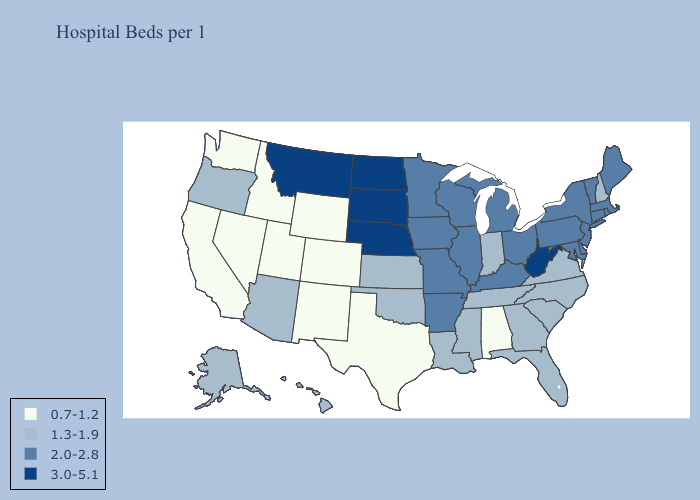Which states hav the highest value in the Northeast?
Quick response, please. Connecticut, Maine, Massachusetts, New Jersey, New York, Pennsylvania, Rhode Island, Vermont. Among the states that border Georgia , which have the lowest value?
Short answer required. Alabama. Does Nebraska have the same value as Kentucky?
Write a very short answer. No. Which states have the highest value in the USA?
Write a very short answer. Montana, Nebraska, North Dakota, South Dakota, West Virginia. What is the highest value in states that border Kansas?
Concise answer only. 3.0-5.1. What is the value of Rhode Island?
Write a very short answer. 2.0-2.8. Is the legend a continuous bar?
Write a very short answer. No. What is the lowest value in states that border Minnesota?
Answer briefly. 2.0-2.8. Does Iowa have the same value as Colorado?
Give a very brief answer. No. How many symbols are there in the legend?
Be succinct. 4. What is the value of Connecticut?
Keep it brief. 2.0-2.8. Name the states that have a value in the range 2.0-2.8?
Be succinct. Arkansas, Connecticut, Delaware, Illinois, Iowa, Kentucky, Maine, Maryland, Massachusetts, Michigan, Minnesota, Missouri, New Jersey, New York, Ohio, Pennsylvania, Rhode Island, Vermont, Wisconsin. Does Arizona have the highest value in the West?
Be succinct. No. Name the states that have a value in the range 0.7-1.2?
Concise answer only. Alabama, California, Colorado, Idaho, Nevada, New Mexico, Texas, Utah, Washington, Wyoming. Name the states that have a value in the range 3.0-5.1?
Keep it brief. Montana, Nebraska, North Dakota, South Dakota, West Virginia. 